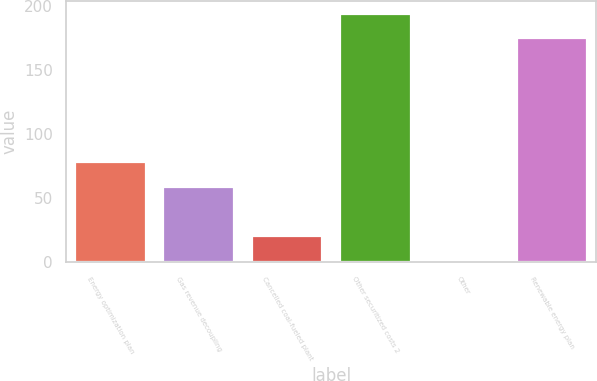Convert chart to OTSL. <chart><loc_0><loc_0><loc_500><loc_500><bar_chart><fcel>Energy optimization plan<fcel>Gas revenue decoupling<fcel>Cancelled coal-fueled plant<fcel>Other securitized costs 2<fcel>Other<fcel>Renewable energy plan<nl><fcel>78<fcel>59<fcel>21<fcel>194<fcel>2<fcel>175<nl></chart> 